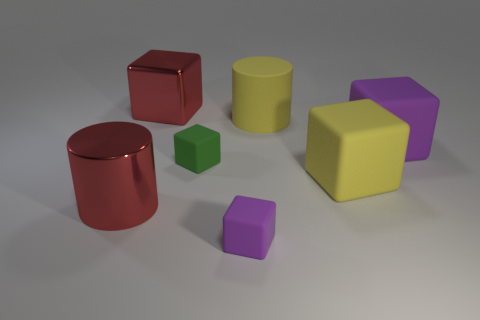The object that is the same color as the big rubber cylinder is what shape?
Your answer should be compact. Cube. What number of purple cubes are made of the same material as the large yellow cylinder?
Provide a short and direct response. 2. What is the color of the rubber cylinder?
Ensure brevity in your answer.  Yellow. What color is the rubber block that is the same size as the green matte thing?
Provide a succinct answer. Purple. Are there any shiny objects of the same color as the metallic block?
Your response must be concise. Yes. There is a tiny object behind the small purple rubber thing; is its shape the same as the big object that is to the left of the large red metallic cube?
Keep it short and to the point. No. There is a metallic cylinder that is the same color as the large metallic cube; what is its size?
Ensure brevity in your answer.  Large. How many other objects are the same size as the yellow matte cube?
Your response must be concise. 4. Do the large rubber cylinder and the small object in front of the tiny green object have the same color?
Provide a succinct answer. No. Are there fewer big red metallic cubes behind the green rubber object than cylinders behind the shiny block?
Your answer should be very brief. No. 